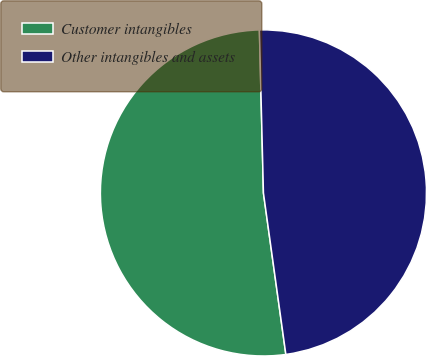Convert chart. <chart><loc_0><loc_0><loc_500><loc_500><pie_chart><fcel>Customer intangibles<fcel>Other intangibles and assets<nl><fcel>51.8%<fcel>48.2%<nl></chart> 